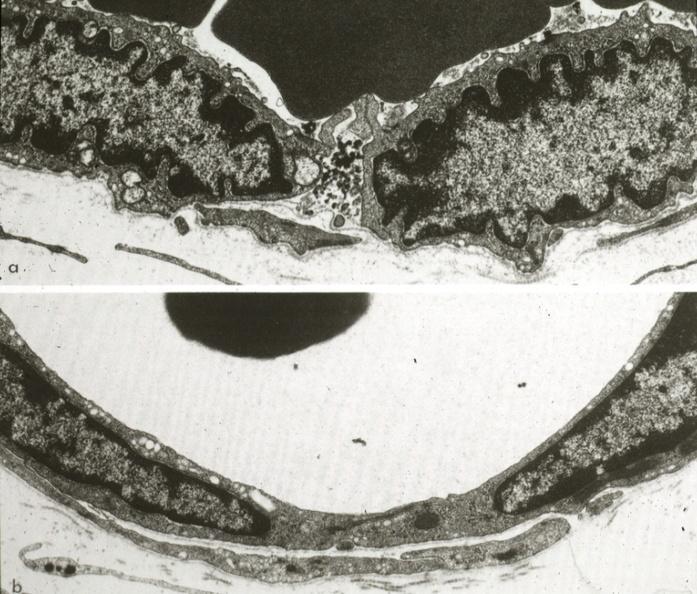s lymphangiomatosis generalized present?
Answer the question using a single word or phrase. No 